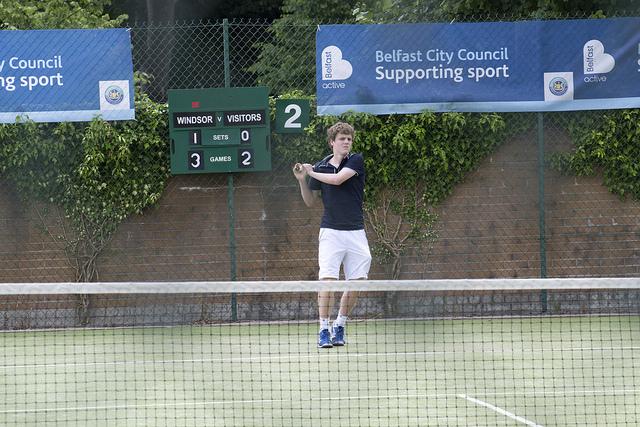What type of sneaker's does the man have?
Answer briefly. Nike. What organization is sponsoring this event?
Answer briefly. Belfast city council. What color are the boy's shorts?
Give a very brief answer. White. 